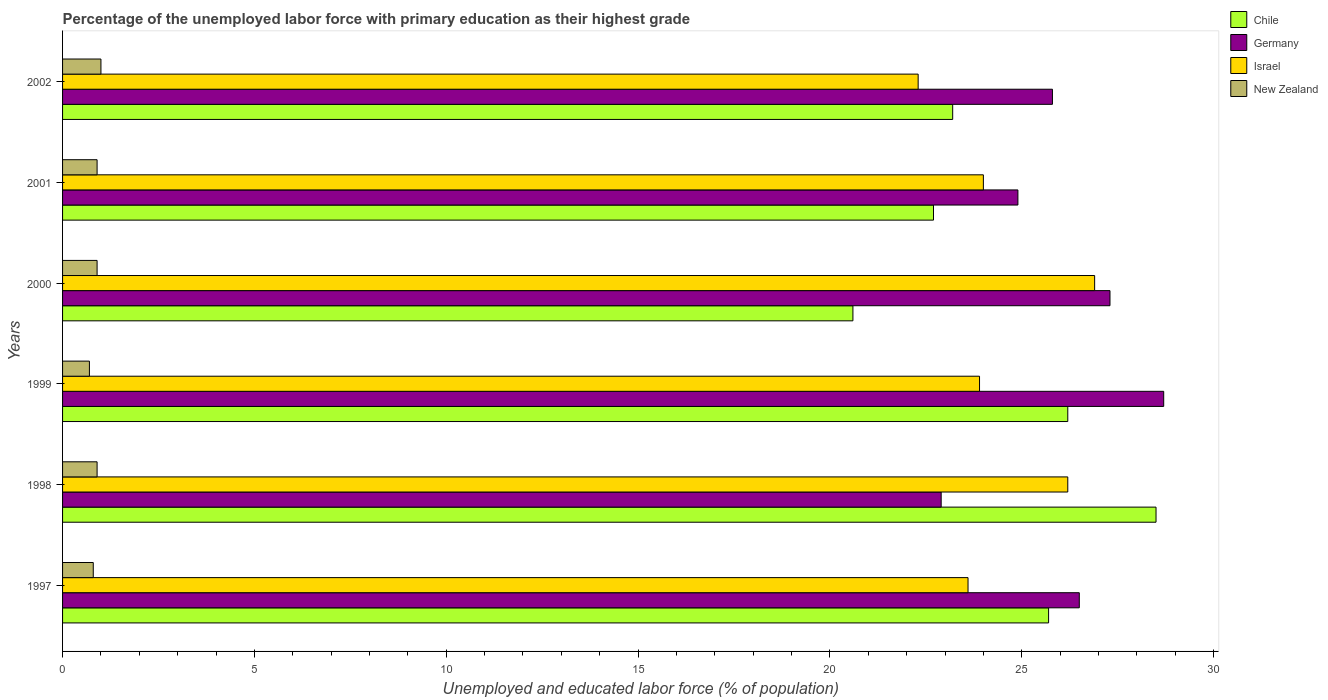How many different coloured bars are there?
Offer a very short reply. 4. How many groups of bars are there?
Provide a short and direct response. 6. Are the number of bars per tick equal to the number of legend labels?
Offer a very short reply. Yes. Are the number of bars on each tick of the Y-axis equal?
Provide a short and direct response. Yes. How many bars are there on the 5th tick from the top?
Your response must be concise. 4. What is the label of the 6th group of bars from the top?
Ensure brevity in your answer.  1997. In how many cases, is the number of bars for a given year not equal to the number of legend labels?
Provide a short and direct response. 0. What is the percentage of the unemployed labor force with primary education in Israel in 1999?
Offer a terse response. 23.9. Across all years, what is the maximum percentage of the unemployed labor force with primary education in Germany?
Your answer should be compact. 28.7. Across all years, what is the minimum percentage of the unemployed labor force with primary education in Israel?
Give a very brief answer. 22.3. What is the total percentage of the unemployed labor force with primary education in Chile in the graph?
Make the answer very short. 146.9. What is the difference between the percentage of the unemployed labor force with primary education in Israel in 1997 and that in 2002?
Your response must be concise. 1.3. What is the difference between the percentage of the unemployed labor force with primary education in Israel in 1997 and the percentage of the unemployed labor force with primary education in Germany in 1999?
Make the answer very short. -5.1. What is the average percentage of the unemployed labor force with primary education in Germany per year?
Your answer should be very brief. 26.02. In the year 2002, what is the difference between the percentage of the unemployed labor force with primary education in Germany and percentage of the unemployed labor force with primary education in New Zealand?
Your answer should be compact. 24.8. In how many years, is the percentage of the unemployed labor force with primary education in Chile greater than 17 %?
Keep it short and to the point. 6. What is the ratio of the percentage of the unemployed labor force with primary education in Germany in 1998 to that in 2001?
Ensure brevity in your answer.  0.92. Is the percentage of the unemployed labor force with primary education in Chile in 2001 less than that in 2002?
Offer a terse response. Yes. Is the difference between the percentage of the unemployed labor force with primary education in Germany in 1999 and 2001 greater than the difference between the percentage of the unemployed labor force with primary education in New Zealand in 1999 and 2001?
Offer a terse response. Yes. What is the difference between the highest and the second highest percentage of the unemployed labor force with primary education in Chile?
Provide a succinct answer. 2.3. What is the difference between the highest and the lowest percentage of the unemployed labor force with primary education in New Zealand?
Give a very brief answer. 0.3. Is the sum of the percentage of the unemployed labor force with primary education in Israel in 1997 and 1998 greater than the maximum percentage of the unemployed labor force with primary education in New Zealand across all years?
Offer a terse response. Yes. What does the 2nd bar from the bottom in 2001 represents?
Your response must be concise. Germany. Is it the case that in every year, the sum of the percentage of the unemployed labor force with primary education in Germany and percentage of the unemployed labor force with primary education in Chile is greater than the percentage of the unemployed labor force with primary education in New Zealand?
Offer a very short reply. Yes. How many bars are there?
Provide a succinct answer. 24. What is the difference between two consecutive major ticks on the X-axis?
Ensure brevity in your answer.  5. Are the values on the major ticks of X-axis written in scientific E-notation?
Offer a terse response. No. How many legend labels are there?
Ensure brevity in your answer.  4. How are the legend labels stacked?
Keep it short and to the point. Vertical. What is the title of the graph?
Your answer should be very brief. Percentage of the unemployed labor force with primary education as their highest grade. Does "High income" appear as one of the legend labels in the graph?
Give a very brief answer. No. What is the label or title of the X-axis?
Make the answer very short. Unemployed and educated labor force (% of population). What is the label or title of the Y-axis?
Provide a short and direct response. Years. What is the Unemployed and educated labor force (% of population) in Chile in 1997?
Provide a short and direct response. 25.7. What is the Unemployed and educated labor force (% of population) in Israel in 1997?
Provide a succinct answer. 23.6. What is the Unemployed and educated labor force (% of population) of New Zealand in 1997?
Offer a terse response. 0.8. What is the Unemployed and educated labor force (% of population) in Chile in 1998?
Offer a terse response. 28.5. What is the Unemployed and educated labor force (% of population) of Germany in 1998?
Offer a terse response. 22.9. What is the Unemployed and educated labor force (% of population) of Israel in 1998?
Provide a short and direct response. 26.2. What is the Unemployed and educated labor force (% of population) of New Zealand in 1998?
Ensure brevity in your answer.  0.9. What is the Unemployed and educated labor force (% of population) in Chile in 1999?
Your answer should be compact. 26.2. What is the Unemployed and educated labor force (% of population) of Germany in 1999?
Ensure brevity in your answer.  28.7. What is the Unemployed and educated labor force (% of population) in Israel in 1999?
Offer a terse response. 23.9. What is the Unemployed and educated labor force (% of population) of New Zealand in 1999?
Your response must be concise. 0.7. What is the Unemployed and educated labor force (% of population) in Chile in 2000?
Keep it short and to the point. 20.6. What is the Unemployed and educated labor force (% of population) of Germany in 2000?
Offer a terse response. 27.3. What is the Unemployed and educated labor force (% of population) in Israel in 2000?
Give a very brief answer. 26.9. What is the Unemployed and educated labor force (% of population) in New Zealand in 2000?
Your response must be concise. 0.9. What is the Unemployed and educated labor force (% of population) of Chile in 2001?
Give a very brief answer. 22.7. What is the Unemployed and educated labor force (% of population) in Germany in 2001?
Keep it short and to the point. 24.9. What is the Unemployed and educated labor force (% of population) of Israel in 2001?
Give a very brief answer. 24. What is the Unemployed and educated labor force (% of population) of New Zealand in 2001?
Make the answer very short. 0.9. What is the Unemployed and educated labor force (% of population) of Chile in 2002?
Make the answer very short. 23.2. What is the Unemployed and educated labor force (% of population) of Germany in 2002?
Make the answer very short. 25.8. What is the Unemployed and educated labor force (% of population) in Israel in 2002?
Give a very brief answer. 22.3. Across all years, what is the maximum Unemployed and educated labor force (% of population) in Chile?
Give a very brief answer. 28.5. Across all years, what is the maximum Unemployed and educated labor force (% of population) in Germany?
Provide a succinct answer. 28.7. Across all years, what is the maximum Unemployed and educated labor force (% of population) in Israel?
Offer a very short reply. 26.9. Across all years, what is the minimum Unemployed and educated labor force (% of population) in Chile?
Your answer should be very brief. 20.6. Across all years, what is the minimum Unemployed and educated labor force (% of population) in Germany?
Give a very brief answer. 22.9. Across all years, what is the minimum Unemployed and educated labor force (% of population) of Israel?
Ensure brevity in your answer.  22.3. Across all years, what is the minimum Unemployed and educated labor force (% of population) in New Zealand?
Your answer should be compact. 0.7. What is the total Unemployed and educated labor force (% of population) in Chile in the graph?
Ensure brevity in your answer.  146.9. What is the total Unemployed and educated labor force (% of population) in Germany in the graph?
Make the answer very short. 156.1. What is the total Unemployed and educated labor force (% of population) in Israel in the graph?
Keep it short and to the point. 146.9. What is the total Unemployed and educated labor force (% of population) in New Zealand in the graph?
Offer a terse response. 5.2. What is the difference between the Unemployed and educated labor force (% of population) in New Zealand in 1997 and that in 1998?
Provide a succinct answer. -0.1. What is the difference between the Unemployed and educated labor force (% of population) of Germany in 1997 and that in 1999?
Your response must be concise. -2.2. What is the difference between the Unemployed and educated labor force (% of population) of Israel in 1997 and that in 1999?
Your answer should be compact. -0.3. What is the difference between the Unemployed and educated labor force (% of population) in New Zealand in 1997 and that in 1999?
Give a very brief answer. 0.1. What is the difference between the Unemployed and educated labor force (% of population) of Chile in 1997 and that in 2000?
Your response must be concise. 5.1. What is the difference between the Unemployed and educated labor force (% of population) of Israel in 1997 and that in 2000?
Your answer should be compact. -3.3. What is the difference between the Unemployed and educated labor force (% of population) in New Zealand in 1997 and that in 2000?
Offer a terse response. -0.1. What is the difference between the Unemployed and educated labor force (% of population) in Chile in 1997 and that in 2001?
Keep it short and to the point. 3. What is the difference between the Unemployed and educated labor force (% of population) in Chile in 1997 and that in 2002?
Give a very brief answer. 2.5. What is the difference between the Unemployed and educated labor force (% of population) in Germany in 1997 and that in 2002?
Offer a terse response. 0.7. What is the difference between the Unemployed and educated labor force (% of population) of Chile in 1998 and that in 1999?
Offer a terse response. 2.3. What is the difference between the Unemployed and educated labor force (% of population) in Germany in 1998 and that in 1999?
Give a very brief answer. -5.8. What is the difference between the Unemployed and educated labor force (% of population) in New Zealand in 1998 and that in 1999?
Make the answer very short. 0.2. What is the difference between the Unemployed and educated labor force (% of population) of Chile in 1998 and that in 2000?
Give a very brief answer. 7.9. What is the difference between the Unemployed and educated labor force (% of population) of New Zealand in 1998 and that in 2000?
Give a very brief answer. 0. What is the difference between the Unemployed and educated labor force (% of population) in Chile in 1998 and that in 2001?
Offer a very short reply. 5.8. What is the difference between the Unemployed and educated labor force (% of population) in Germany in 1998 and that in 2001?
Offer a terse response. -2. What is the difference between the Unemployed and educated labor force (% of population) of Israel in 1998 and that in 2001?
Ensure brevity in your answer.  2.2. What is the difference between the Unemployed and educated labor force (% of population) of New Zealand in 1998 and that in 2001?
Provide a short and direct response. 0. What is the difference between the Unemployed and educated labor force (% of population) of Chile in 1998 and that in 2002?
Ensure brevity in your answer.  5.3. What is the difference between the Unemployed and educated labor force (% of population) in Germany in 1998 and that in 2002?
Provide a short and direct response. -2.9. What is the difference between the Unemployed and educated labor force (% of population) in Israel in 1998 and that in 2002?
Your response must be concise. 3.9. What is the difference between the Unemployed and educated labor force (% of population) of New Zealand in 1998 and that in 2002?
Keep it short and to the point. -0.1. What is the difference between the Unemployed and educated labor force (% of population) of Germany in 1999 and that in 2000?
Provide a short and direct response. 1.4. What is the difference between the Unemployed and educated labor force (% of population) of Israel in 1999 and that in 2000?
Offer a very short reply. -3. What is the difference between the Unemployed and educated labor force (% of population) in Germany in 1999 and that in 2001?
Your answer should be very brief. 3.8. What is the difference between the Unemployed and educated labor force (% of population) of Israel in 1999 and that in 2002?
Your answer should be very brief. 1.6. What is the difference between the Unemployed and educated labor force (% of population) in New Zealand in 1999 and that in 2002?
Keep it short and to the point. -0.3. What is the difference between the Unemployed and educated labor force (% of population) in Chile in 2000 and that in 2002?
Offer a terse response. -2.6. What is the difference between the Unemployed and educated labor force (% of population) in Germany in 2000 and that in 2002?
Your answer should be very brief. 1.5. What is the difference between the Unemployed and educated labor force (% of population) in Israel in 2000 and that in 2002?
Your response must be concise. 4.6. What is the difference between the Unemployed and educated labor force (% of population) of New Zealand in 2001 and that in 2002?
Ensure brevity in your answer.  -0.1. What is the difference between the Unemployed and educated labor force (% of population) of Chile in 1997 and the Unemployed and educated labor force (% of population) of New Zealand in 1998?
Give a very brief answer. 24.8. What is the difference between the Unemployed and educated labor force (% of population) of Germany in 1997 and the Unemployed and educated labor force (% of population) of Israel in 1998?
Keep it short and to the point. 0.3. What is the difference between the Unemployed and educated labor force (% of population) of Germany in 1997 and the Unemployed and educated labor force (% of population) of New Zealand in 1998?
Make the answer very short. 25.6. What is the difference between the Unemployed and educated labor force (% of population) in Israel in 1997 and the Unemployed and educated labor force (% of population) in New Zealand in 1998?
Provide a succinct answer. 22.7. What is the difference between the Unemployed and educated labor force (% of population) of Germany in 1997 and the Unemployed and educated labor force (% of population) of Israel in 1999?
Your answer should be very brief. 2.6. What is the difference between the Unemployed and educated labor force (% of population) in Germany in 1997 and the Unemployed and educated labor force (% of population) in New Zealand in 1999?
Ensure brevity in your answer.  25.8. What is the difference between the Unemployed and educated labor force (% of population) in Israel in 1997 and the Unemployed and educated labor force (% of population) in New Zealand in 1999?
Make the answer very short. 22.9. What is the difference between the Unemployed and educated labor force (% of population) of Chile in 1997 and the Unemployed and educated labor force (% of population) of Germany in 2000?
Offer a very short reply. -1.6. What is the difference between the Unemployed and educated labor force (% of population) of Chile in 1997 and the Unemployed and educated labor force (% of population) of Israel in 2000?
Offer a terse response. -1.2. What is the difference between the Unemployed and educated labor force (% of population) in Chile in 1997 and the Unemployed and educated labor force (% of population) in New Zealand in 2000?
Your response must be concise. 24.8. What is the difference between the Unemployed and educated labor force (% of population) of Germany in 1997 and the Unemployed and educated labor force (% of population) of New Zealand in 2000?
Keep it short and to the point. 25.6. What is the difference between the Unemployed and educated labor force (% of population) of Israel in 1997 and the Unemployed and educated labor force (% of population) of New Zealand in 2000?
Offer a very short reply. 22.7. What is the difference between the Unemployed and educated labor force (% of population) of Chile in 1997 and the Unemployed and educated labor force (% of population) of Germany in 2001?
Your response must be concise. 0.8. What is the difference between the Unemployed and educated labor force (% of population) in Chile in 1997 and the Unemployed and educated labor force (% of population) in New Zealand in 2001?
Provide a succinct answer. 24.8. What is the difference between the Unemployed and educated labor force (% of population) of Germany in 1997 and the Unemployed and educated labor force (% of population) of Israel in 2001?
Your answer should be very brief. 2.5. What is the difference between the Unemployed and educated labor force (% of population) in Germany in 1997 and the Unemployed and educated labor force (% of population) in New Zealand in 2001?
Keep it short and to the point. 25.6. What is the difference between the Unemployed and educated labor force (% of population) of Israel in 1997 and the Unemployed and educated labor force (% of population) of New Zealand in 2001?
Offer a very short reply. 22.7. What is the difference between the Unemployed and educated labor force (% of population) of Chile in 1997 and the Unemployed and educated labor force (% of population) of Israel in 2002?
Make the answer very short. 3.4. What is the difference between the Unemployed and educated labor force (% of population) of Chile in 1997 and the Unemployed and educated labor force (% of population) of New Zealand in 2002?
Provide a short and direct response. 24.7. What is the difference between the Unemployed and educated labor force (% of population) of Israel in 1997 and the Unemployed and educated labor force (% of population) of New Zealand in 2002?
Keep it short and to the point. 22.6. What is the difference between the Unemployed and educated labor force (% of population) of Chile in 1998 and the Unemployed and educated labor force (% of population) of New Zealand in 1999?
Give a very brief answer. 27.8. What is the difference between the Unemployed and educated labor force (% of population) in Germany in 1998 and the Unemployed and educated labor force (% of population) in New Zealand in 1999?
Provide a short and direct response. 22.2. What is the difference between the Unemployed and educated labor force (% of population) in Chile in 1998 and the Unemployed and educated labor force (% of population) in Germany in 2000?
Your answer should be compact. 1.2. What is the difference between the Unemployed and educated labor force (% of population) of Chile in 1998 and the Unemployed and educated labor force (% of population) of New Zealand in 2000?
Provide a succinct answer. 27.6. What is the difference between the Unemployed and educated labor force (% of population) of Germany in 1998 and the Unemployed and educated labor force (% of population) of Israel in 2000?
Your answer should be very brief. -4. What is the difference between the Unemployed and educated labor force (% of population) in Israel in 1998 and the Unemployed and educated labor force (% of population) in New Zealand in 2000?
Your answer should be very brief. 25.3. What is the difference between the Unemployed and educated labor force (% of population) of Chile in 1998 and the Unemployed and educated labor force (% of population) of New Zealand in 2001?
Make the answer very short. 27.6. What is the difference between the Unemployed and educated labor force (% of population) in Germany in 1998 and the Unemployed and educated labor force (% of population) in Israel in 2001?
Make the answer very short. -1.1. What is the difference between the Unemployed and educated labor force (% of population) of Germany in 1998 and the Unemployed and educated labor force (% of population) of New Zealand in 2001?
Your answer should be compact. 22. What is the difference between the Unemployed and educated labor force (% of population) of Israel in 1998 and the Unemployed and educated labor force (% of population) of New Zealand in 2001?
Ensure brevity in your answer.  25.3. What is the difference between the Unemployed and educated labor force (% of population) in Chile in 1998 and the Unemployed and educated labor force (% of population) in Germany in 2002?
Ensure brevity in your answer.  2.7. What is the difference between the Unemployed and educated labor force (% of population) in Chile in 1998 and the Unemployed and educated labor force (% of population) in New Zealand in 2002?
Provide a succinct answer. 27.5. What is the difference between the Unemployed and educated labor force (% of population) of Germany in 1998 and the Unemployed and educated labor force (% of population) of New Zealand in 2002?
Provide a short and direct response. 21.9. What is the difference between the Unemployed and educated labor force (% of population) in Israel in 1998 and the Unemployed and educated labor force (% of population) in New Zealand in 2002?
Offer a very short reply. 25.2. What is the difference between the Unemployed and educated labor force (% of population) of Chile in 1999 and the Unemployed and educated labor force (% of population) of Germany in 2000?
Your answer should be very brief. -1.1. What is the difference between the Unemployed and educated labor force (% of population) in Chile in 1999 and the Unemployed and educated labor force (% of population) in New Zealand in 2000?
Offer a very short reply. 25.3. What is the difference between the Unemployed and educated labor force (% of population) in Germany in 1999 and the Unemployed and educated labor force (% of population) in Israel in 2000?
Give a very brief answer. 1.8. What is the difference between the Unemployed and educated labor force (% of population) in Germany in 1999 and the Unemployed and educated labor force (% of population) in New Zealand in 2000?
Offer a very short reply. 27.8. What is the difference between the Unemployed and educated labor force (% of population) in Israel in 1999 and the Unemployed and educated labor force (% of population) in New Zealand in 2000?
Make the answer very short. 23. What is the difference between the Unemployed and educated labor force (% of population) of Chile in 1999 and the Unemployed and educated labor force (% of population) of Germany in 2001?
Your answer should be very brief. 1.3. What is the difference between the Unemployed and educated labor force (% of population) in Chile in 1999 and the Unemployed and educated labor force (% of population) in Israel in 2001?
Your answer should be very brief. 2.2. What is the difference between the Unemployed and educated labor force (% of population) in Chile in 1999 and the Unemployed and educated labor force (% of population) in New Zealand in 2001?
Keep it short and to the point. 25.3. What is the difference between the Unemployed and educated labor force (% of population) of Germany in 1999 and the Unemployed and educated labor force (% of population) of New Zealand in 2001?
Give a very brief answer. 27.8. What is the difference between the Unemployed and educated labor force (% of population) in Israel in 1999 and the Unemployed and educated labor force (% of population) in New Zealand in 2001?
Your answer should be compact. 23. What is the difference between the Unemployed and educated labor force (% of population) in Chile in 1999 and the Unemployed and educated labor force (% of population) in Germany in 2002?
Your answer should be compact. 0.4. What is the difference between the Unemployed and educated labor force (% of population) of Chile in 1999 and the Unemployed and educated labor force (% of population) of Israel in 2002?
Provide a succinct answer. 3.9. What is the difference between the Unemployed and educated labor force (% of population) of Chile in 1999 and the Unemployed and educated labor force (% of population) of New Zealand in 2002?
Offer a very short reply. 25.2. What is the difference between the Unemployed and educated labor force (% of population) of Germany in 1999 and the Unemployed and educated labor force (% of population) of Israel in 2002?
Provide a succinct answer. 6.4. What is the difference between the Unemployed and educated labor force (% of population) of Germany in 1999 and the Unemployed and educated labor force (% of population) of New Zealand in 2002?
Provide a short and direct response. 27.7. What is the difference between the Unemployed and educated labor force (% of population) in Israel in 1999 and the Unemployed and educated labor force (% of population) in New Zealand in 2002?
Your answer should be very brief. 22.9. What is the difference between the Unemployed and educated labor force (% of population) in Chile in 2000 and the Unemployed and educated labor force (% of population) in New Zealand in 2001?
Provide a succinct answer. 19.7. What is the difference between the Unemployed and educated labor force (% of population) in Germany in 2000 and the Unemployed and educated labor force (% of population) in Israel in 2001?
Provide a succinct answer. 3.3. What is the difference between the Unemployed and educated labor force (% of population) of Germany in 2000 and the Unemployed and educated labor force (% of population) of New Zealand in 2001?
Provide a succinct answer. 26.4. What is the difference between the Unemployed and educated labor force (% of population) of Israel in 2000 and the Unemployed and educated labor force (% of population) of New Zealand in 2001?
Provide a succinct answer. 26. What is the difference between the Unemployed and educated labor force (% of population) of Chile in 2000 and the Unemployed and educated labor force (% of population) of Germany in 2002?
Your answer should be very brief. -5.2. What is the difference between the Unemployed and educated labor force (% of population) in Chile in 2000 and the Unemployed and educated labor force (% of population) in Israel in 2002?
Give a very brief answer. -1.7. What is the difference between the Unemployed and educated labor force (% of population) of Chile in 2000 and the Unemployed and educated labor force (% of population) of New Zealand in 2002?
Ensure brevity in your answer.  19.6. What is the difference between the Unemployed and educated labor force (% of population) of Germany in 2000 and the Unemployed and educated labor force (% of population) of New Zealand in 2002?
Offer a very short reply. 26.3. What is the difference between the Unemployed and educated labor force (% of population) in Israel in 2000 and the Unemployed and educated labor force (% of population) in New Zealand in 2002?
Your answer should be very brief. 25.9. What is the difference between the Unemployed and educated labor force (% of population) of Chile in 2001 and the Unemployed and educated labor force (% of population) of Germany in 2002?
Your response must be concise. -3.1. What is the difference between the Unemployed and educated labor force (% of population) in Chile in 2001 and the Unemployed and educated labor force (% of population) in New Zealand in 2002?
Keep it short and to the point. 21.7. What is the difference between the Unemployed and educated labor force (% of population) of Germany in 2001 and the Unemployed and educated labor force (% of population) of Israel in 2002?
Your answer should be very brief. 2.6. What is the difference between the Unemployed and educated labor force (% of population) in Germany in 2001 and the Unemployed and educated labor force (% of population) in New Zealand in 2002?
Your response must be concise. 23.9. What is the average Unemployed and educated labor force (% of population) in Chile per year?
Provide a short and direct response. 24.48. What is the average Unemployed and educated labor force (% of population) of Germany per year?
Make the answer very short. 26.02. What is the average Unemployed and educated labor force (% of population) of Israel per year?
Your answer should be compact. 24.48. What is the average Unemployed and educated labor force (% of population) in New Zealand per year?
Your answer should be compact. 0.87. In the year 1997, what is the difference between the Unemployed and educated labor force (% of population) of Chile and Unemployed and educated labor force (% of population) of Germany?
Your answer should be compact. -0.8. In the year 1997, what is the difference between the Unemployed and educated labor force (% of population) in Chile and Unemployed and educated labor force (% of population) in Israel?
Provide a short and direct response. 2.1. In the year 1997, what is the difference between the Unemployed and educated labor force (% of population) in Chile and Unemployed and educated labor force (% of population) in New Zealand?
Offer a terse response. 24.9. In the year 1997, what is the difference between the Unemployed and educated labor force (% of population) of Germany and Unemployed and educated labor force (% of population) of New Zealand?
Provide a short and direct response. 25.7. In the year 1997, what is the difference between the Unemployed and educated labor force (% of population) of Israel and Unemployed and educated labor force (% of population) of New Zealand?
Your answer should be very brief. 22.8. In the year 1998, what is the difference between the Unemployed and educated labor force (% of population) of Chile and Unemployed and educated labor force (% of population) of Germany?
Your response must be concise. 5.6. In the year 1998, what is the difference between the Unemployed and educated labor force (% of population) of Chile and Unemployed and educated labor force (% of population) of New Zealand?
Offer a terse response. 27.6. In the year 1998, what is the difference between the Unemployed and educated labor force (% of population) of Germany and Unemployed and educated labor force (% of population) of New Zealand?
Your answer should be very brief. 22. In the year 1998, what is the difference between the Unemployed and educated labor force (% of population) of Israel and Unemployed and educated labor force (% of population) of New Zealand?
Provide a short and direct response. 25.3. In the year 1999, what is the difference between the Unemployed and educated labor force (% of population) in Chile and Unemployed and educated labor force (% of population) in Israel?
Your response must be concise. 2.3. In the year 1999, what is the difference between the Unemployed and educated labor force (% of population) in Germany and Unemployed and educated labor force (% of population) in Israel?
Provide a short and direct response. 4.8. In the year 1999, what is the difference between the Unemployed and educated labor force (% of population) of Israel and Unemployed and educated labor force (% of population) of New Zealand?
Keep it short and to the point. 23.2. In the year 2000, what is the difference between the Unemployed and educated labor force (% of population) of Germany and Unemployed and educated labor force (% of population) of Israel?
Your response must be concise. 0.4. In the year 2000, what is the difference between the Unemployed and educated labor force (% of population) of Germany and Unemployed and educated labor force (% of population) of New Zealand?
Give a very brief answer. 26.4. In the year 2000, what is the difference between the Unemployed and educated labor force (% of population) in Israel and Unemployed and educated labor force (% of population) in New Zealand?
Your answer should be compact. 26. In the year 2001, what is the difference between the Unemployed and educated labor force (% of population) of Chile and Unemployed and educated labor force (% of population) of Germany?
Your answer should be very brief. -2.2. In the year 2001, what is the difference between the Unemployed and educated labor force (% of population) of Chile and Unemployed and educated labor force (% of population) of Israel?
Ensure brevity in your answer.  -1.3. In the year 2001, what is the difference between the Unemployed and educated labor force (% of population) in Chile and Unemployed and educated labor force (% of population) in New Zealand?
Offer a terse response. 21.8. In the year 2001, what is the difference between the Unemployed and educated labor force (% of population) in Germany and Unemployed and educated labor force (% of population) in Israel?
Provide a succinct answer. 0.9. In the year 2001, what is the difference between the Unemployed and educated labor force (% of population) in Israel and Unemployed and educated labor force (% of population) in New Zealand?
Provide a succinct answer. 23.1. In the year 2002, what is the difference between the Unemployed and educated labor force (% of population) of Chile and Unemployed and educated labor force (% of population) of Germany?
Your answer should be compact. -2.6. In the year 2002, what is the difference between the Unemployed and educated labor force (% of population) in Germany and Unemployed and educated labor force (% of population) in Israel?
Keep it short and to the point. 3.5. In the year 2002, what is the difference between the Unemployed and educated labor force (% of population) of Germany and Unemployed and educated labor force (% of population) of New Zealand?
Make the answer very short. 24.8. In the year 2002, what is the difference between the Unemployed and educated labor force (% of population) of Israel and Unemployed and educated labor force (% of population) of New Zealand?
Make the answer very short. 21.3. What is the ratio of the Unemployed and educated labor force (% of population) of Chile in 1997 to that in 1998?
Offer a terse response. 0.9. What is the ratio of the Unemployed and educated labor force (% of population) of Germany in 1997 to that in 1998?
Your answer should be very brief. 1.16. What is the ratio of the Unemployed and educated labor force (% of population) of Israel in 1997 to that in 1998?
Ensure brevity in your answer.  0.9. What is the ratio of the Unemployed and educated labor force (% of population) of Chile in 1997 to that in 1999?
Give a very brief answer. 0.98. What is the ratio of the Unemployed and educated labor force (% of population) in Germany in 1997 to that in 1999?
Give a very brief answer. 0.92. What is the ratio of the Unemployed and educated labor force (% of population) of Israel in 1997 to that in 1999?
Ensure brevity in your answer.  0.99. What is the ratio of the Unemployed and educated labor force (% of population) in New Zealand in 1997 to that in 1999?
Keep it short and to the point. 1.14. What is the ratio of the Unemployed and educated labor force (% of population) in Chile in 1997 to that in 2000?
Your response must be concise. 1.25. What is the ratio of the Unemployed and educated labor force (% of population) of Germany in 1997 to that in 2000?
Ensure brevity in your answer.  0.97. What is the ratio of the Unemployed and educated labor force (% of population) in Israel in 1997 to that in 2000?
Your response must be concise. 0.88. What is the ratio of the Unemployed and educated labor force (% of population) of Chile in 1997 to that in 2001?
Give a very brief answer. 1.13. What is the ratio of the Unemployed and educated labor force (% of population) of Germany in 1997 to that in 2001?
Ensure brevity in your answer.  1.06. What is the ratio of the Unemployed and educated labor force (% of population) in Israel in 1997 to that in 2001?
Your answer should be very brief. 0.98. What is the ratio of the Unemployed and educated labor force (% of population) of New Zealand in 1997 to that in 2001?
Give a very brief answer. 0.89. What is the ratio of the Unemployed and educated labor force (% of population) in Chile in 1997 to that in 2002?
Ensure brevity in your answer.  1.11. What is the ratio of the Unemployed and educated labor force (% of population) in Germany in 1997 to that in 2002?
Provide a short and direct response. 1.03. What is the ratio of the Unemployed and educated labor force (% of population) in Israel in 1997 to that in 2002?
Provide a short and direct response. 1.06. What is the ratio of the Unemployed and educated labor force (% of population) in Chile in 1998 to that in 1999?
Offer a very short reply. 1.09. What is the ratio of the Unemployed and educated labor force (% of population) of Germany in 1998 to that in 1999?
Keep it short and to the point. 0.8. What is the ratio of the Unemployed and educated labor force (% of population) of Israel in 1998 to that in 1999?
Offer a very short reply. 1.1. What is the ratio of the Unemployed and educated labor force (% of population) in New Zealand in 1998 to that in 1999?
Provide a succinct answer. 1.29. What is the ratio of the Unemployed and educated labor force (% of population) of Chile in 1998 to that in 2000?
Your answer should be compact. 1.38. What is the ratio of the Unemployed and educated labor force (% of population) in Germany in 1998 to that in 2000?
Your response must be concise. 0.84. What is the ratio of the Unemployed and educated labor force (% of population) of Israel in 1998 to that in 2000?
Make the answer very short. 0.97. What is the ratio of the Unemployed and educated labor force (% of population) of New Zealand in 1998 to that in 2000?
Provide a succinct answer. 1. What is the ratio of the Unemployed and educated labor force (% of population) of Chile in 1998 to that in 2001?
Your answer should be compact. 1.26. What is the ratio of the Unemployed and educated labor force (% of population) of Germany in 1998 to that in 2001?
Make the answer very short. 0.92. What is the ratio of the Unemployed and educated labor force (% of population) in Israel in 1998 to that in 2001?
Ensure brevity in your answer.  1.09. What is the ratio of the Unemployed and educated labor force (% of population) in Chile in 1998 to that in 2002?
Provide a short and direct response. 1.23. What is the ratio of the Unemployed and educated labor force (% of population) of Germany in 1998 to that in 2002?
Provide a succinct answer. 0.89. What is the ratio of the Unemployed and educated labor force (% of population) in Israel in 1998 to that in 2002?
Your response must be concise. 1.17. What is the ratio of the Unemployed and educated labor force (% of population) of New Zealand in 1998 to that in 2002?
Your answer should be compact. 0.9. What is the ratio of the Unemployed and educated labor force (% of population) in Chile in 1999 to that in 2000?
Make the answer very short. 1.27. What is the ratio of the Unemployed and educated labor force (% of population) in Germany in 1999 to that in 2000?
Offer a very short reply. 1.05. What is the ratio of the Unemployed and educated labor force (% of population) of Israel in 1999 to that in 2000?
Offer a terse response. 0.89. What is the ratio of the Unemployed and educated labor force (% of population) in Chile in 1999 to that in 2001?
Give a very brief answer. 1.15. What is the ratio of the Unemployed and educated labor force (% of population) in Germany in 1999 to that in 2001?
Offer a very short reply. 1.15. What is the ratio of the Unemployed and educated labor force (% of population) of Israel in 1999 to that in 2001?
Offer a terse response. 1. What is the ratio of the Unemployed and educated labor force (% of population) in New Zealand in 1999 to that in 2001?
Provide a succinct answer. 0.78. What is the ratio of the Unemployed and educated labor force (% of population) of Chile in 1999 to that in 2002?
Your response must be concise. 1.13. What is the ratio of the Unemployed and educated labor force (% of population) of Germany in 1999 to that in 2002?
Offer a terse response. 1.11. What is the ratio of the Unemployed and educated labor force (% of population) of Israel in 1999 to that in 2002?
Ensure brevity in your answer.  1.07. What is the ratio of the Unemployed and educated labor force (% of population) in Chile in 2000 to that in 2001?
Offer a terse response. 0.91. What is the ratio of the Unemployed and educated labor force (% of population) in Germany in 2000 to that in 2001?
Ensure brevity in your answer.  1.1. What is the ratio of the Unemployed and educated labor force (% of population) of Israel in 2000 to that in 2001?
Give a very brief answer. 1.12. What is the ratio of the Unemployed and educated labor force (% of population) of Chile in 2000 to that in 2002?
Give a very brief answer. 0.89. What is the ratio of the Unemployed and educated labor force (% of population) in Germany in 2000 to that in 2002?
Ensure brevity in your answer.  1.06. What is the ratio of the Unemployed and educated labor force (% of population) of Israel in 2000 to that in 2002?
Offer a terse response. 1.21. What is the ratio of the Unemployed and educated labor force (% of population) in Chile in 2001 to that in 2002?
Ensure brevity in your answer.  0.98. What is the ratio of the Unemployed and educated labor force (% of population) in Germany in 2001 to that in 2002?
Offer a very short reply. 0.97. What is the ratio of the Unemployed and educated labor force (% of population) in Israel in 2001 to that in 2002?
Provide a short and direct response. 1.08. What is the difference between the highest and the second highest Unemployed and educated labor force (% of population) in Germany?
Keep it short and to the point. 1.4. What is the difference between the highest and the second highest Unemployed and educated labor force (% of population) in Israel?
Your answer should be compact. 0.7. What is the difference between the highest and the second highest Unemployed and educated labor force (% of population) in New Zealand?
Give a very brief answer. 0.1. What is the difference between the highest and the lowest Unemployed and educated labor force (% of population) in Germany?
Provide a succinct answer. 5.8. 